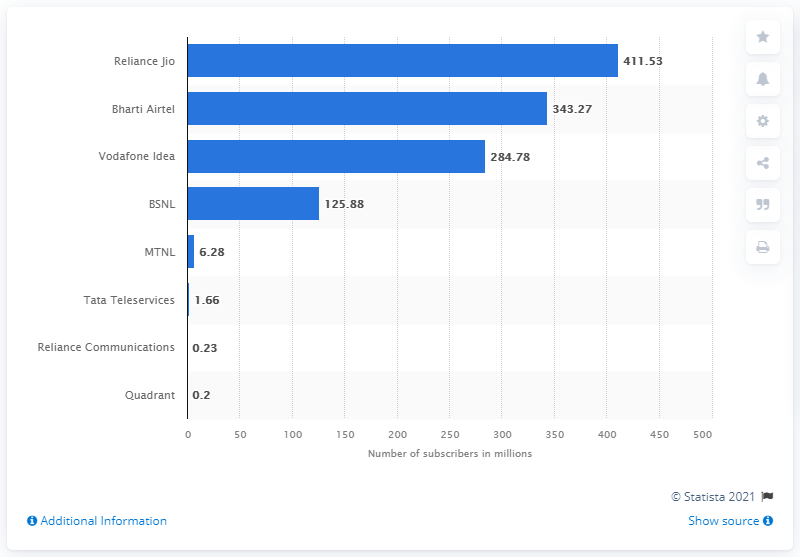Identify some key points in this picture. At the end of 2020, Reliance Jio had approximately 411.53 subscribers in India. 